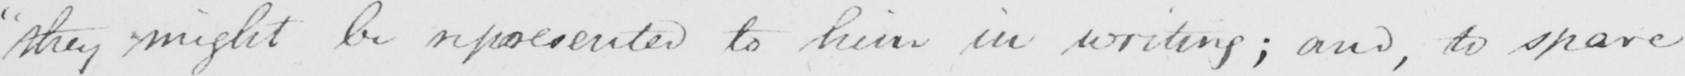What is written in this line of handwriting? " they might be represented to him in writing ; and , to spare 